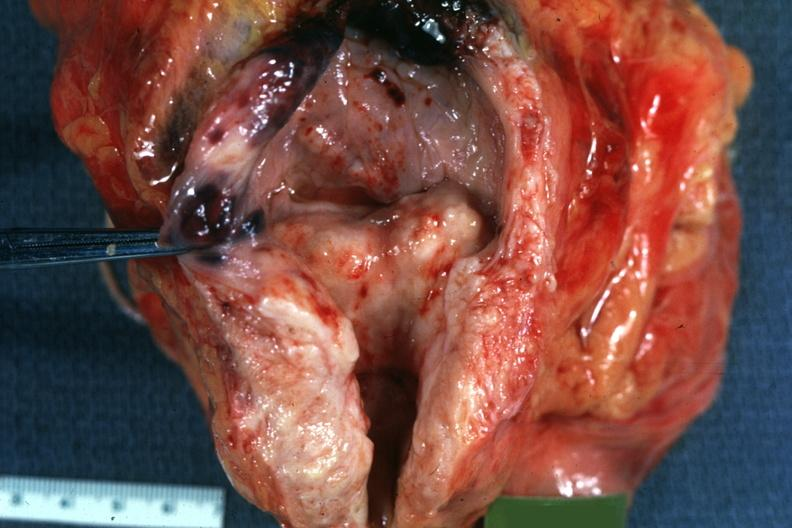what does this image show?
Answer the question using a single word or phrase. Median bar bladder hypertrophy good 